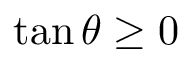Convert formula to latex. <formula><loc_0><loc_0><loc_500><loc_500>\tan \theta \geq 0</formula> 